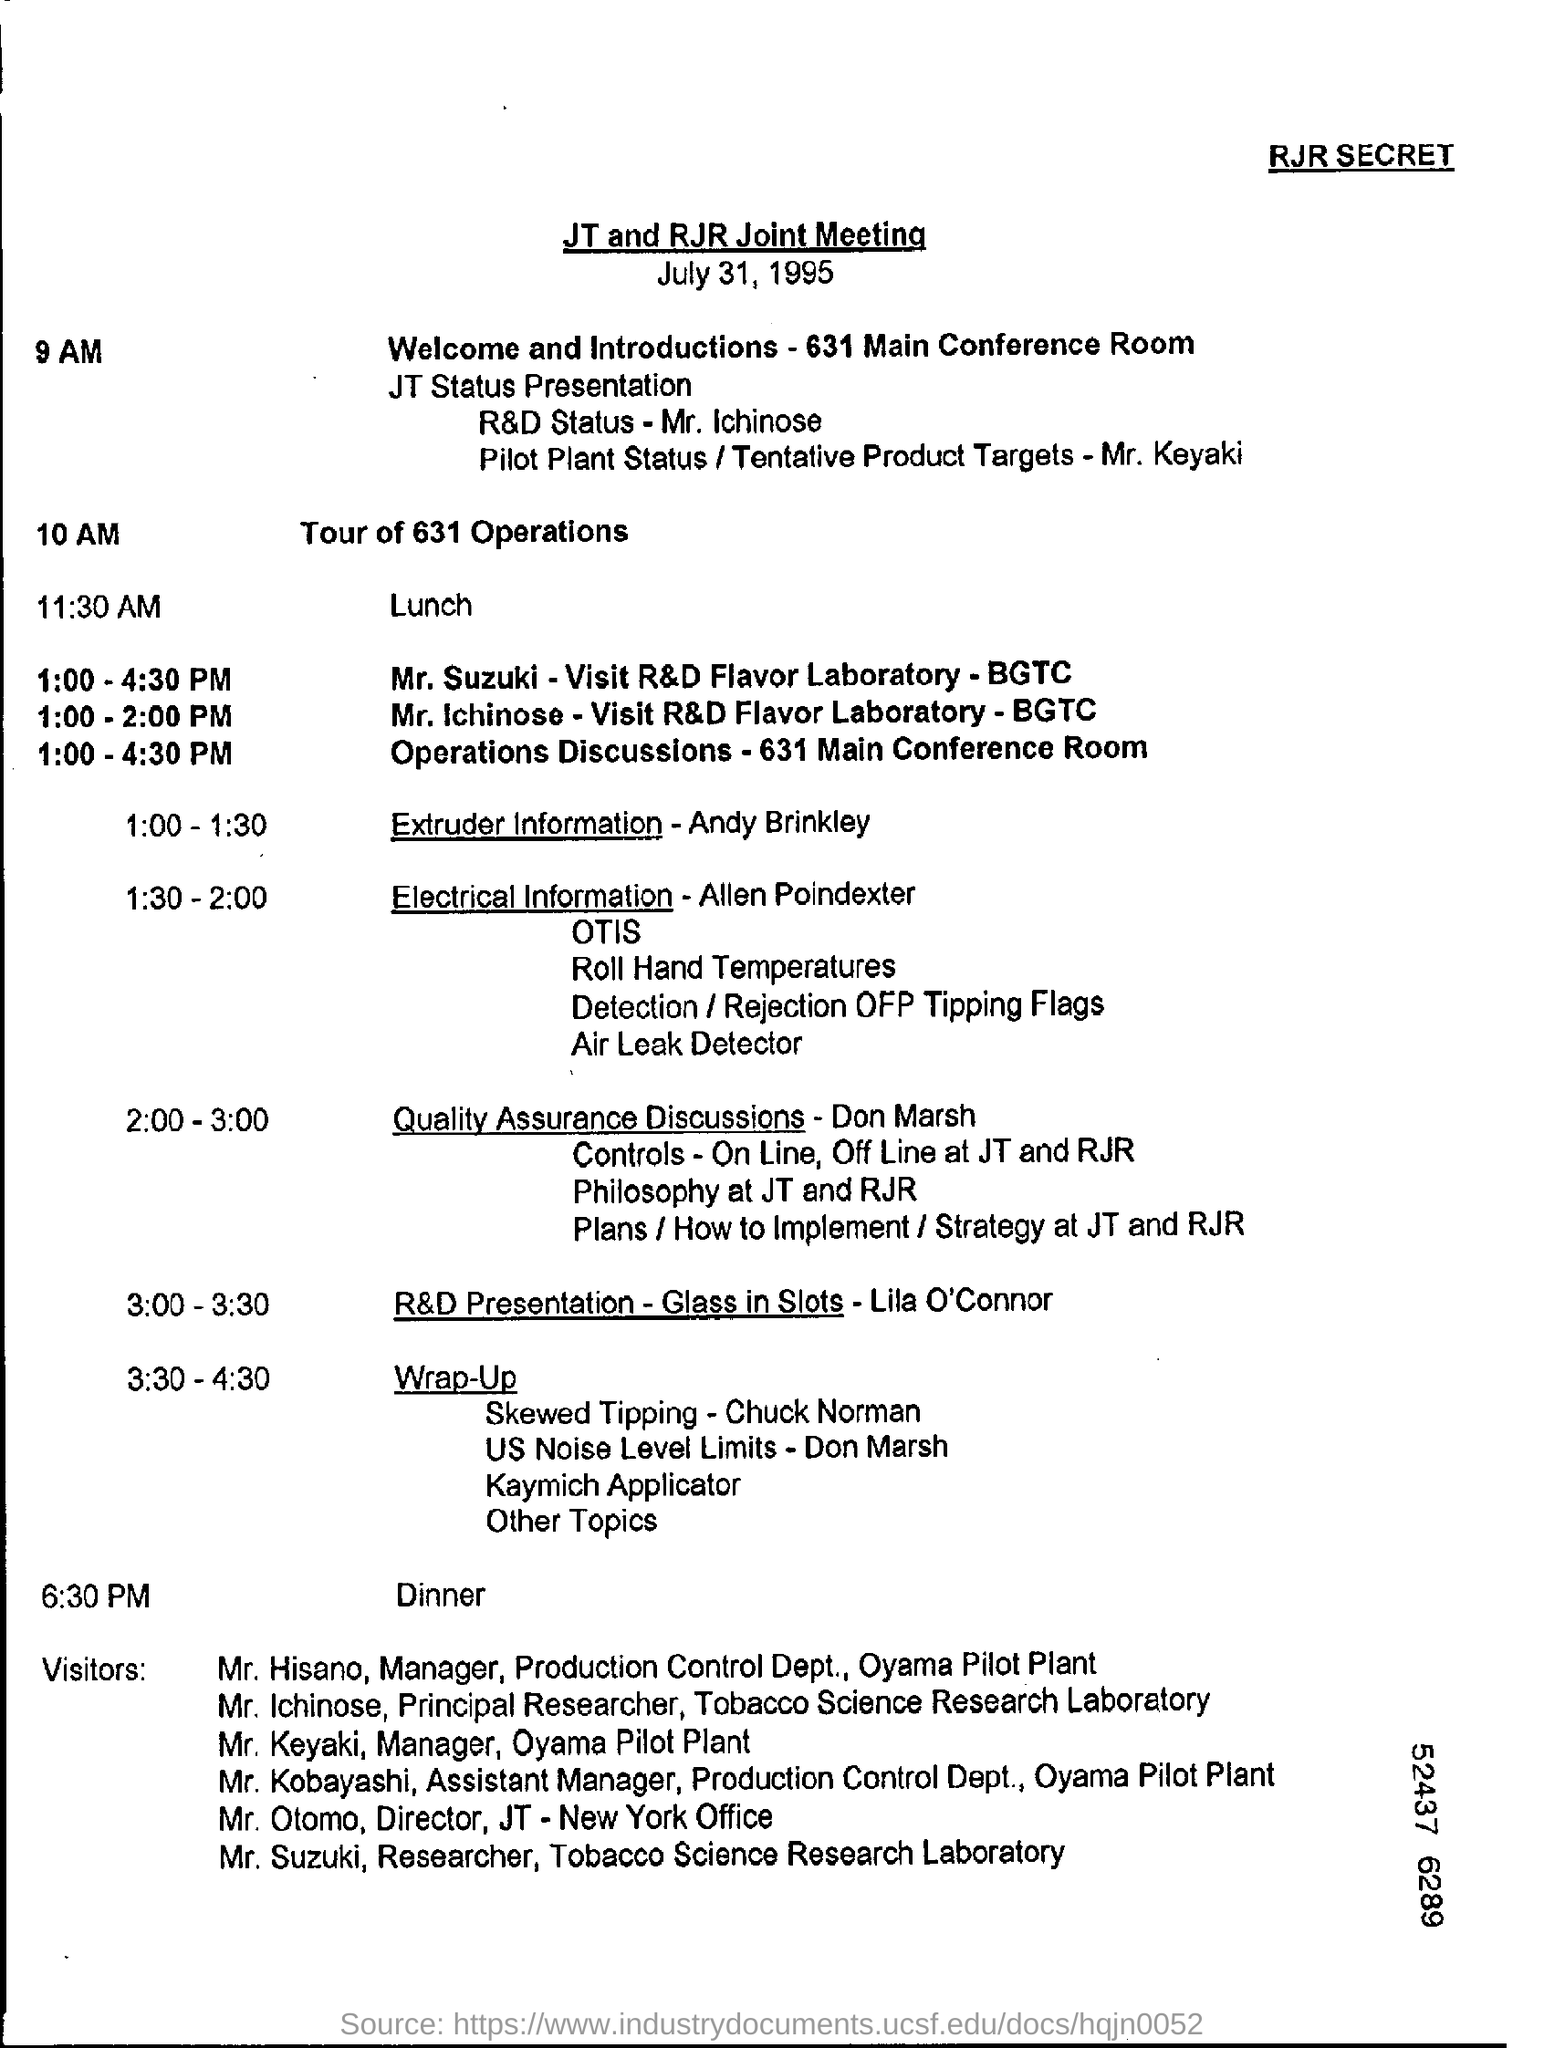What is the event at 10 am?
Offer a terse response. Tour of 631 Operations. Who is visiting R&D Flavor Laboratory - BGTC from 1:00 - 2:00 PM?
Your answer should be very brief. Mr. Ichinose. When is the dinner scheduled?
Make the answer very short. 6:30 PM. 